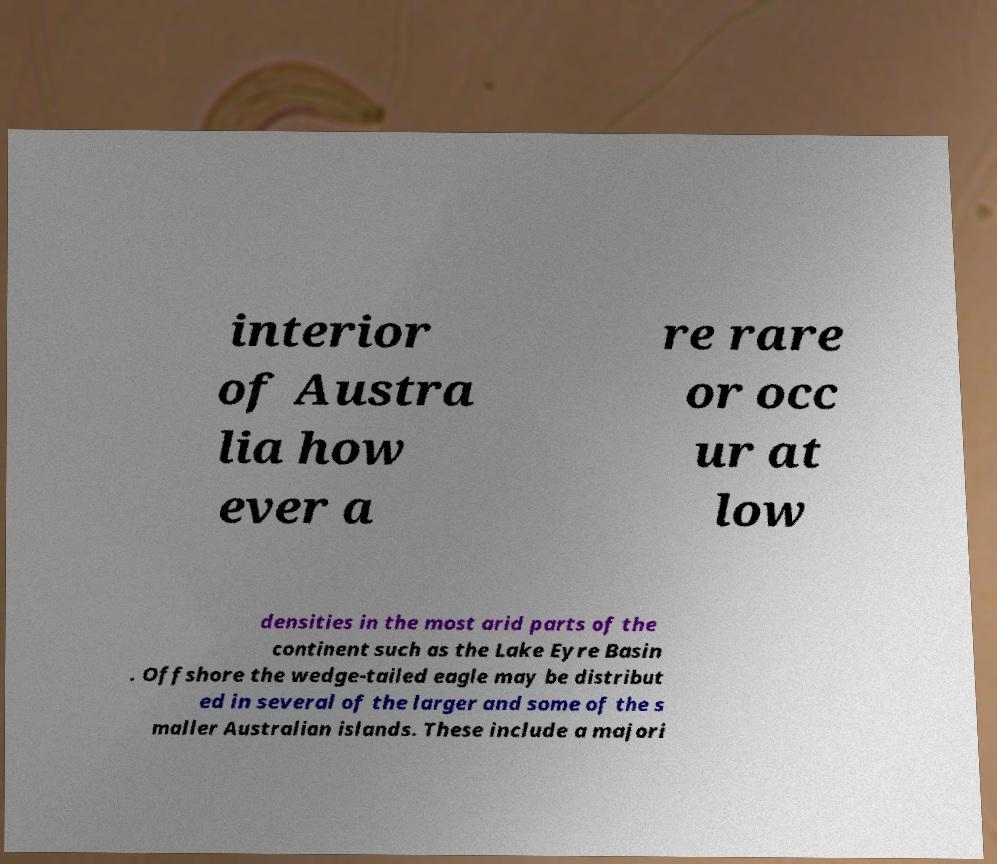Can you accurately transcribe the text from the provided image for me? interior of Austra lia how ever a re rare or occ ur at low densities in the most arid parts of the continent such as the Lake Eyre Basin . Offshore the wedge-tailed eagle may be distribut ed in several of the larger and some of the s maller Australian islands. These include a majori 